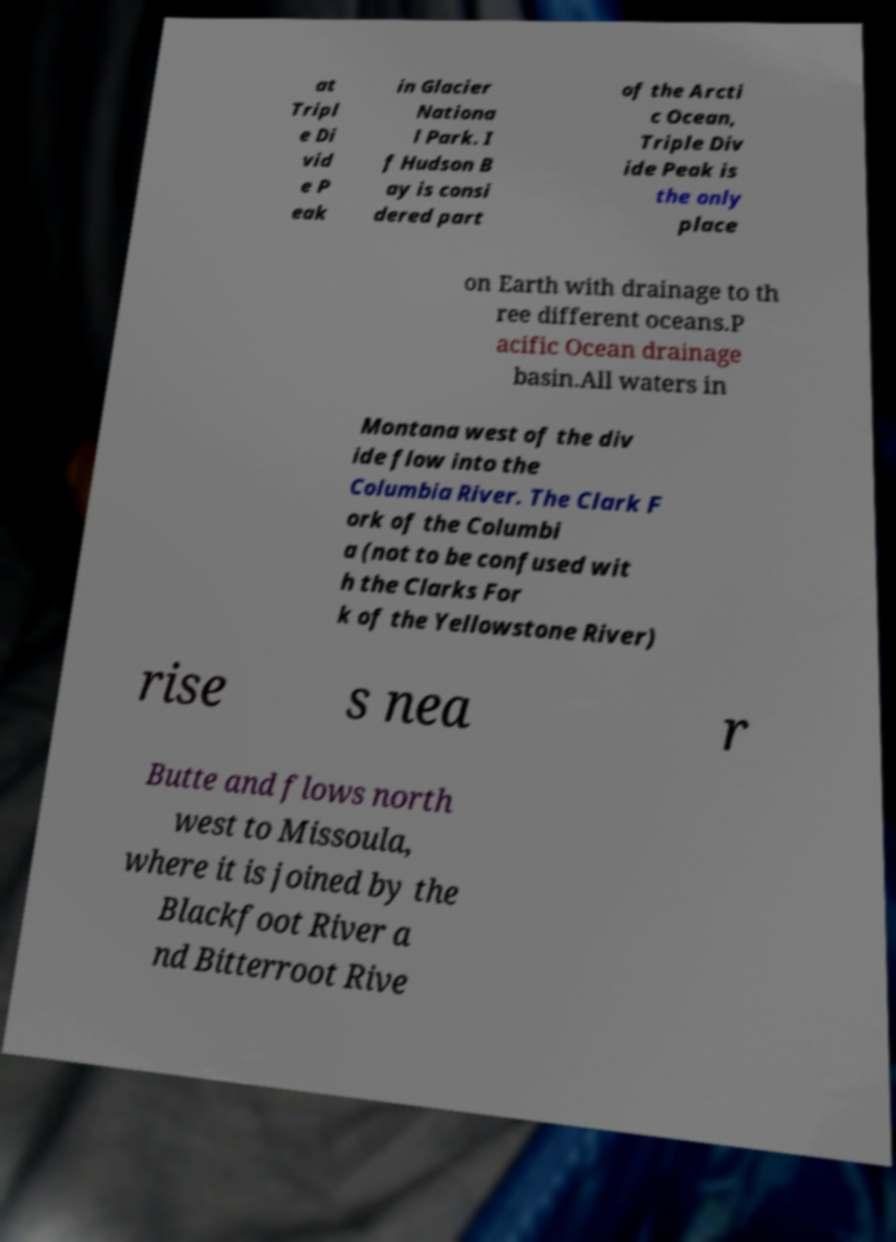For documentation purposes, I need the text within this image transcribed. Could you provide that? at Tripl e Di vid e P eak in Glacier Nationa l Park. I f Hudson B ay is consi dered part of the Arcti c Ocean, Triple Div ide Peak is the only place on Earth with drainage to th ree different oceans.P acific Ocean drainage basin.All waters in Montana west of the div ide flow into the Columbia River. The Clark F ork of the Columbi a (not to be confused wit h the Clarks For k of the Yellowstone River) rise s nea r Butte and flows north west to Missoula, where it is joined by the Blackfoot River a nd Bitterroot Rive 